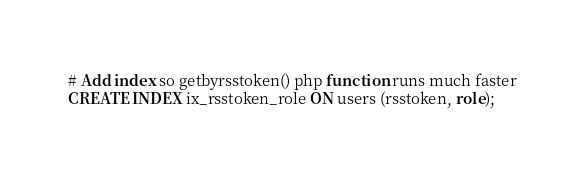<code> <loc_0><loc_0><loc_500><loc_500><_SQL_># Add index so getbyrsstoken() php function runs much faster
CREATE INDEX ix_rsstoken_role ON users (rsstoken, role);
</code> 